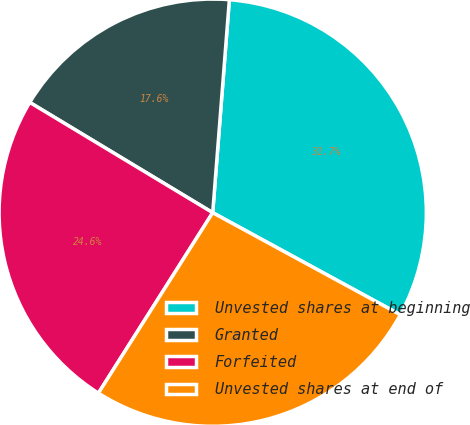<chart> <loc_0><loc_0><loc_500><loc_500><pie_chart><fcel>Unvested shares at beginning<fcel>Granted<fcel>Forfeited<fcel>Unvested shares at end of<nl><fcel>31.69%<fcel>17.61%<fcel>24.65%<fcel>26.06%<nl></chart> 